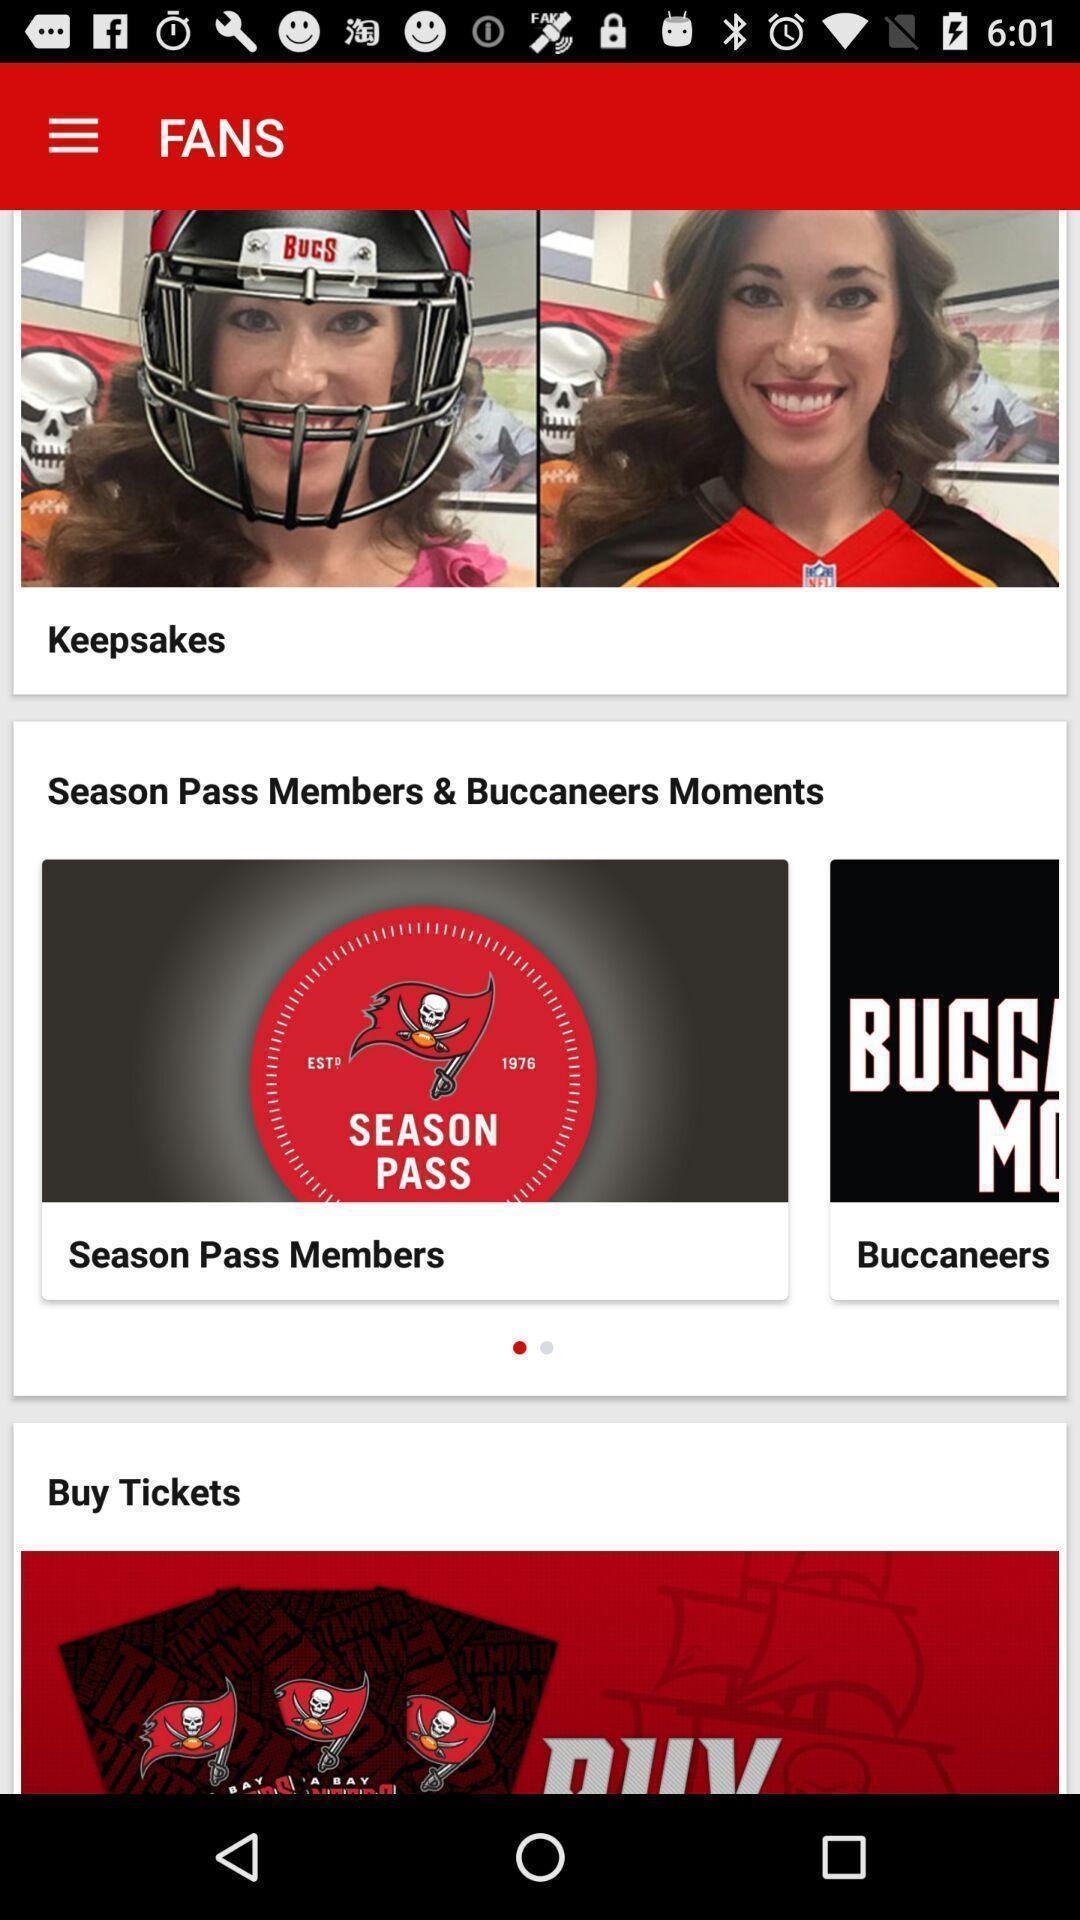What details can you identify in this image? Page showing different options on a sports app. 